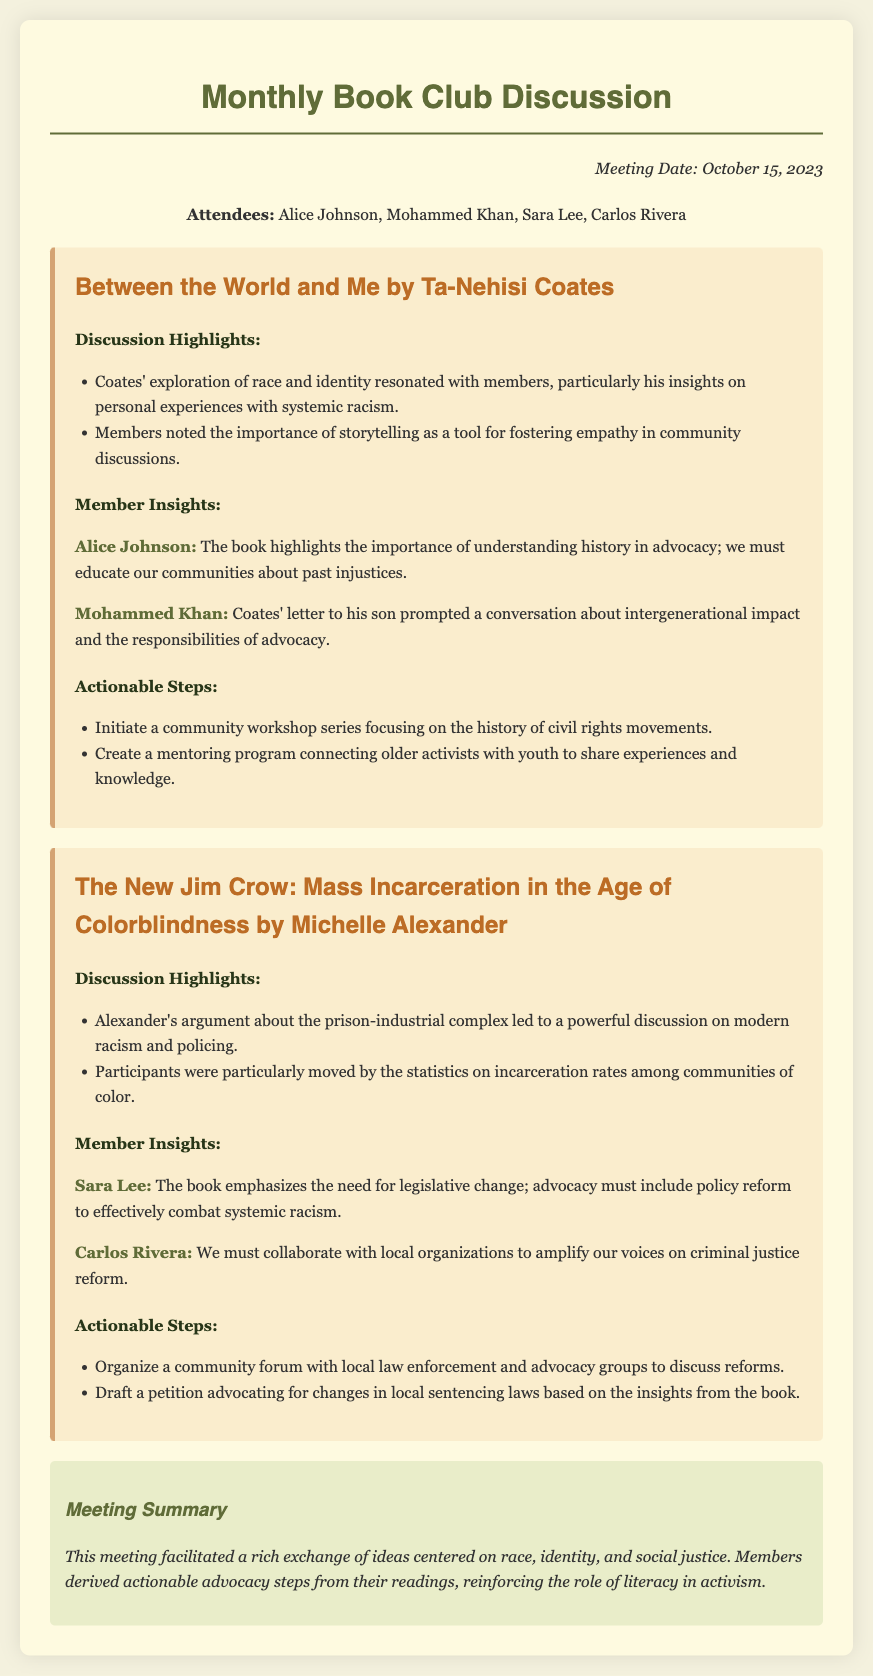what is the meeting date? The meeting date is clearly stated in the document as October 15, 2023.
Answer: October 15, 2023 who authored "Between the World and Me"? The document specifies that the book was authored by Ta-Nehisi Coates.
Answer: Ta-Nehisi Coates which member emphasized the importance of understanding history in advocacy? The insights from the meeting reveal that Alice Johnson made this emphasis.
Answer: Alice Johnson what is one actionable step proposed related to "The New Jim Crow"? The document lists various actions, one being to organize a community forum with local law enforcement.
Answer: Organize a community forum how many members attended the meeting? Four members are listed as attendees in the document.
Answer: Four what is a theme discussed regarding "The New Jim Crow"? The discussion highlighted the prison-industrial complex and modern racism.
Answer: Modern racism name one member who talked about policy reform. Sara Lee is identified as the member who mentioned the need for legislative change.
Answer: Sara Lee what type of literature was the focus of the book club? The document indicates that the focus was on literature addressing social justice issues.
Answer: Social justice what was the purpose of the meeting? The purpose outlined is to facilitate discussions on race, identity, and advocacy based on the readings.
Answer: Discussions on race, identity, and advocacy 